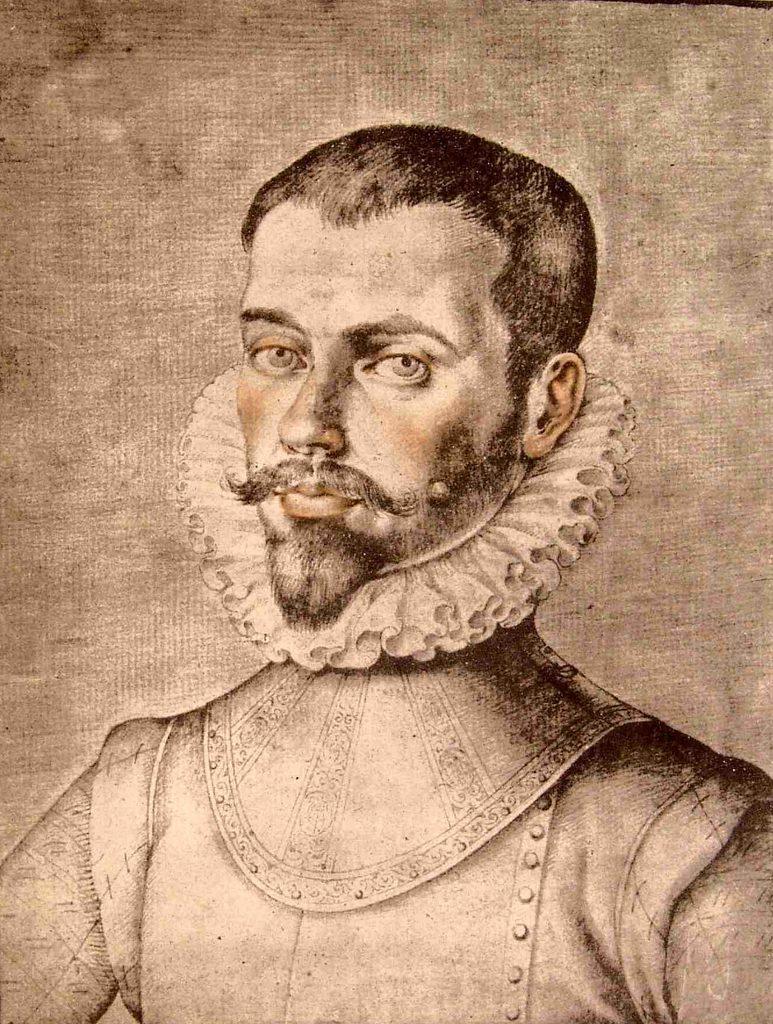Could you give a brief overview of what you see in this image? In this picture we can observe a sketch of a man on the cream color surface. This sketch is in black color. 